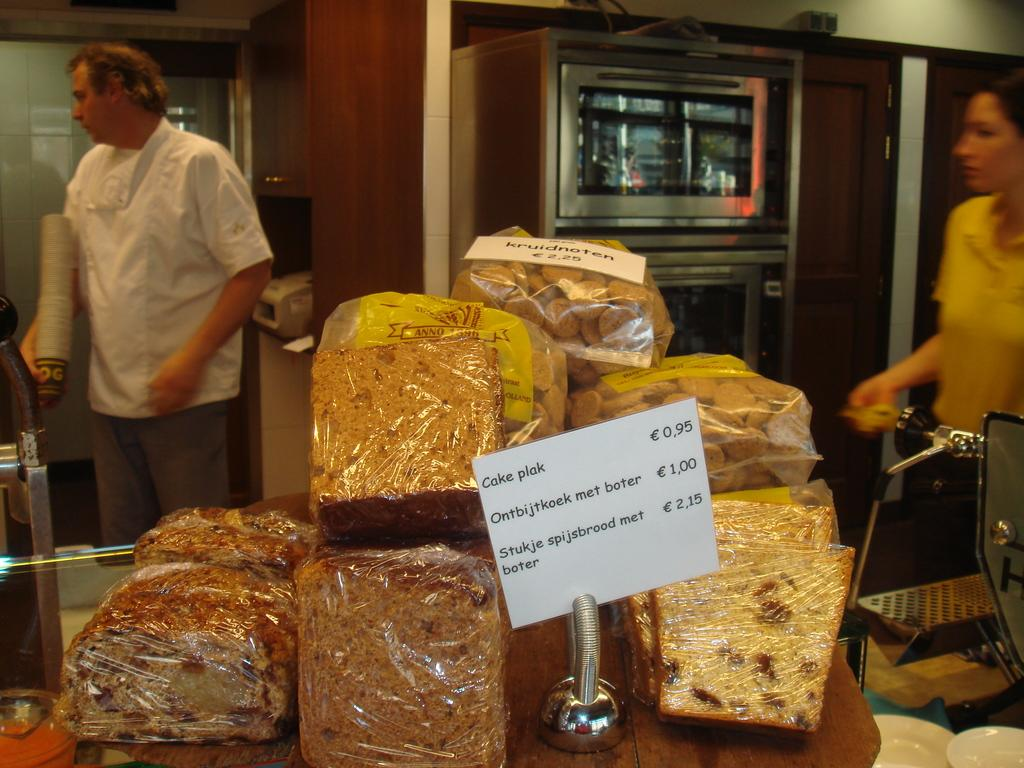What can be seen on the table in the image? There are food items on the table in the image. What is the color of the board visible in the image? The color board in the image is white. Can you describe the people in the background of the image? Two persons are standing in the background of the image. What type of appliance is visible in the background? There is an oven visible in the background. What type of pan is being used to cook the dinner in the image? There is no dinner or pan present in the image. How many people are in the group standing in the background of the image? There are no groups in the image; only two persons are standing in the background. 